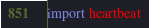<code> <loc_0><loc_0><loc_500><loc_500><_Python_>
import heartbeat
</code> 